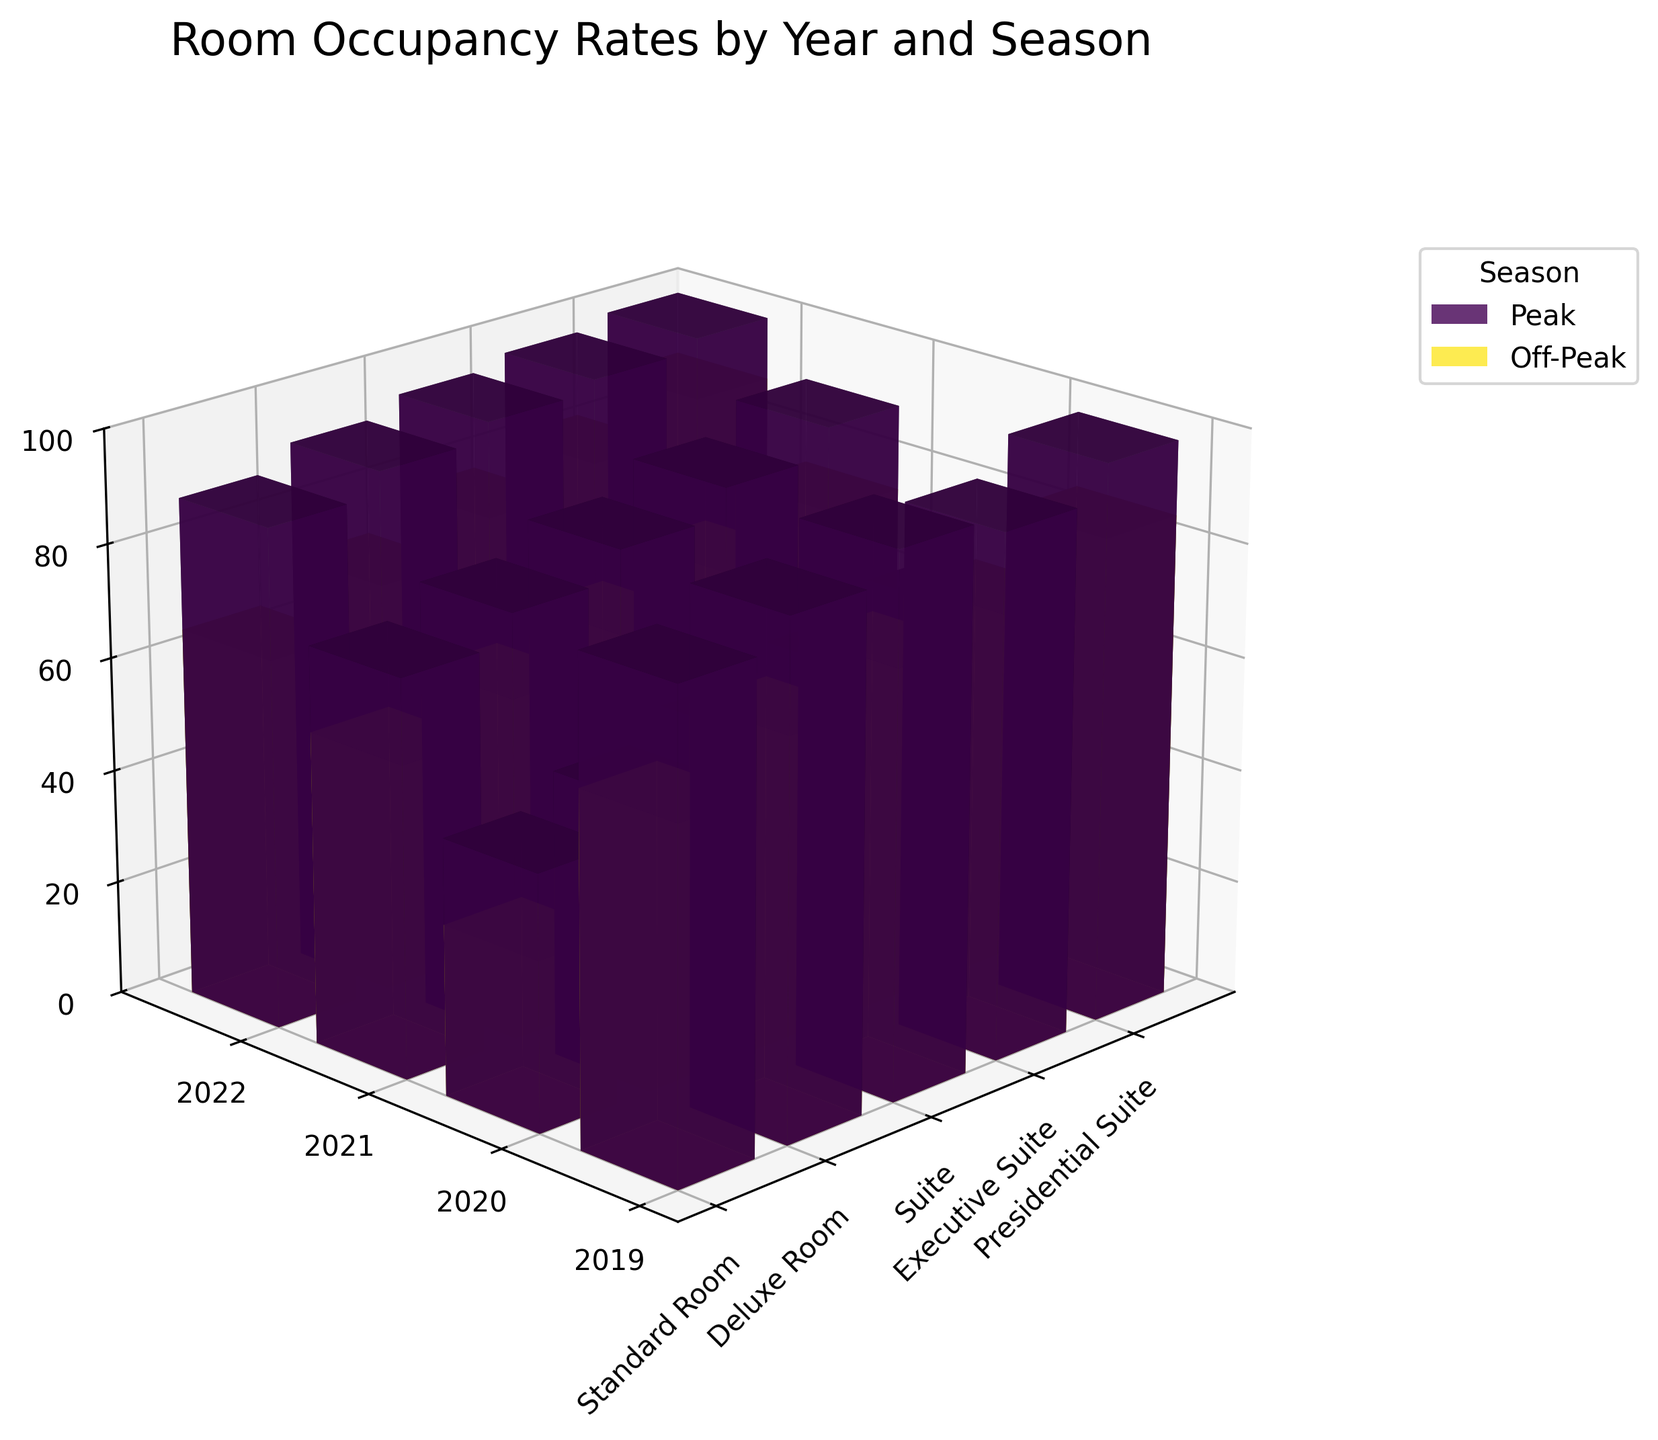Which year has the highest peak season occupancy rate for the Presidential Suite? The highest peak season occupancy rate for the Presidential Suite can be identified by looking at the tallest bar in the 3D bar plot that represents the peak season for Presidential Suites across the years. The tallest bar is in 2022.
Answer: 2022 Which room type had the lowest occupancy rate during the off-peak season in 2020? The lowest occupancy rate during the off-peak season in 2020 can be found by looking at the shortest bar for the off-peak season in 2020. The shortest bar represents the Standard Room.
Answer: Standard Room How does the peak season occupancy rate for Executive Suites in 2021 compare to 2020? By comparing the heights of the bars representing the peak season occupancy rate for Executive Suites in 2021 and 2020, we can see that the bar for 2021 is taller than the bar for 2020, indicating a higher occupancy rate in 2021.
Answer: Higher in 2021 What is the average peak season occupancy rate for Standard Rooms over the years? To find the average peak season occupancy rate for Standard Rooms, sum the occupancy rates for Standard Rooms in peak seasons (85 in 2019, 45 in 2020, 70 in 2021, 88 in 2022) and divide by the number of years. (85 + 45 + 70 + 88) / 4 = 72
Answer: 72 Which room type experienced the highest increase in occupancy rate from off-peak season in 2020 to peak season in 2021? The increase in occupancy rate can be calculated for each room type by subtracting the off-peak season rate of 2020 from the peak season rate of 2021. The differences are: Standard Room (70-30=40), Deluxe Room (75-35=40), Suite (80-40=40), Executive Suite (85-45=40), Presidential Suite (90-50=40). All room types experienced the same increase.
Answer: All room types Which season generally has higher occupancy rates across all room types? By comparing the colors representing the bars, one for peak season and another for off-peak season across all room types, we can visually see that bars for peak seasons are generally taller, indicating higher occupancy rates.
Answer: Peak Is there a significant change in the occupancy rates for any room type from 2020 to 2021? A significant change in occupancy rates can be observed by comparing the 3D bars from 2020 to 2021. Notably, all room types show an increase in occupancy rates from 2020 to 2021, especially the Suites and Executive Suites.
Answer: Yes What trend is noticeable in the occupancy rates for Deluxe Rooms over the years during the peak season? Observing the height of the bars representing Deluxe Rooms during the peak season over the years, there is a noticeable dip in 2020 followed by a recovery and rise in 2021 and 2022.
Answer: Dip in 2020, rise thereafter 